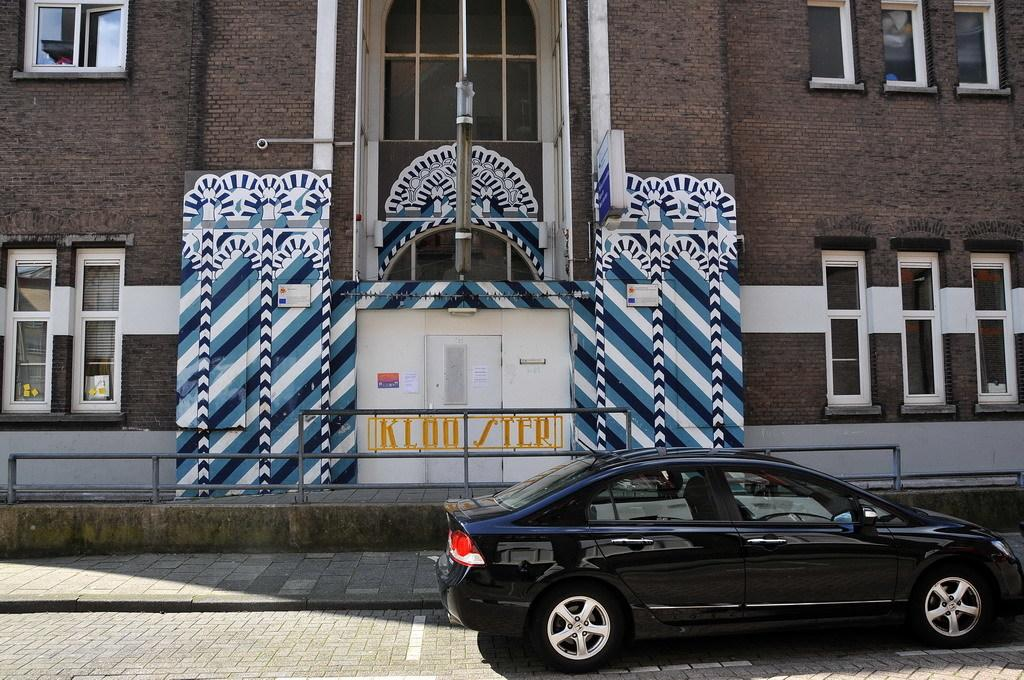What color is the car in the image? The car in the image is black. Where is the car located in the image? The car is in the front of the image. What can be seen in the background of the image? There is a building in the background of the image. What features does the building have? The building has windows and a door. How many mint leaves are on the car's hood in the image? There are no mint leaves present on the car's hood in the image. 